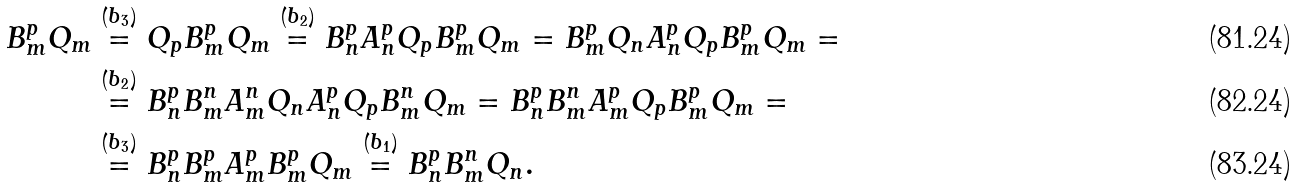Convert formula to latex. <formula><loc_0><loc_0><loc_500><loc_500>{ B } _ { m } ^ { p } Q _ { m } & \stackrel { ( b _ { 3 } ) } { = } Q _ { p } { B } _ { m } ^ { p } Q _ { m } \stackrel { ( b _ { 2 } ) } { = } { B } _ { n } ^ { p } { A } _ { n } ^ { p } Q _ { p } { B } _ { m } ^ { p } Q _ { m } = { B } _ { m } ^ { p } Q _ { n } { A } _ { n } ^ { p } Q _ { p } { B } _ { m } ^ { p } Q _ { m } = \\ & \stackrel { ( b _ { 2 } ) } { = } { B } _ { n } ^ { p } { B } _ { m } ^ { n } { A } _ { m } ^ { n } Q _ { n } { A } _ { n } ^ { p } Q _ { p } { B } _ { m } ^ { n } Q _ { m } = { B } _ { n } ^ { p } { B } _ { m } ^ { n } { A } _ { m } ^ { p } Q _ { p } { B } _ { m } ^ { p } Q _ { m } = \\ & \stackrel { ( b _ { 3 } ) } { = } { B } _ { n } ^ { p } { B } _ { m } ^ { p } { A } _ { m } ^ { p } { B } _ { m } ^ { p } Q _ { m } \stackrel { ( b _ { 1 } ) } { = } { B } _ { n } ^ { p } { B } _ { m } ^ { n } Q _ { n } .</formula> 